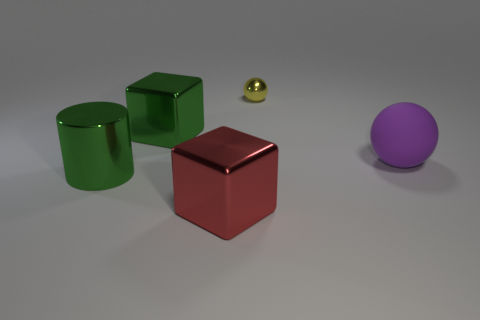Add 3 big purple spheres. How many objects exist? 8 Subtract all cylinders. How many objects are left? 4 Subtract all small red shiny blocks. Subtract all big matte balls. How many objects are left? 4 Add 1 small yellow things. How many small yellow things are left? 2 Add 1 large red cubes. How many large red cubes exist? 2 Subtract 0 blue cubes. How many objects are left? 5 